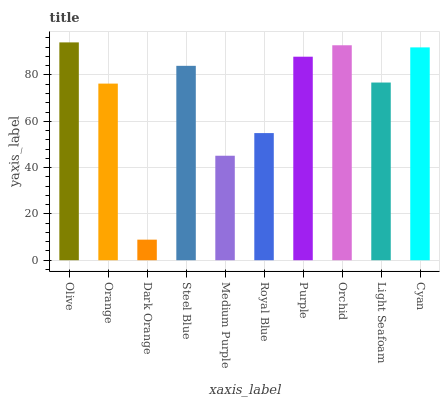Is Dark Orange the minimum?
Answer yes or no. Yes. Is Olive the maximum?
Answer yes or no. Yes. Is Orange the minimum?
Answer yes or no. No. Is Orange the maximum?
Answer yes or no. No. Is Olive greater than Orange?
Answer yes or no. Yes. Is Orange less than Olive?
Answer yes or no. Yes. Is Orange greater than Olive?
Answer yes or no. No. Is Olive less than Orange?
Answer yes or no. No. Is Steel Blue the high median?
Answer yes or no. Yes. Is Light Seafoam the low median?
Answer yes or no. Yes. Is Cyan the high median?
Answer yes or no. No. Is Olive the low median?
Answer yes or no. No. 